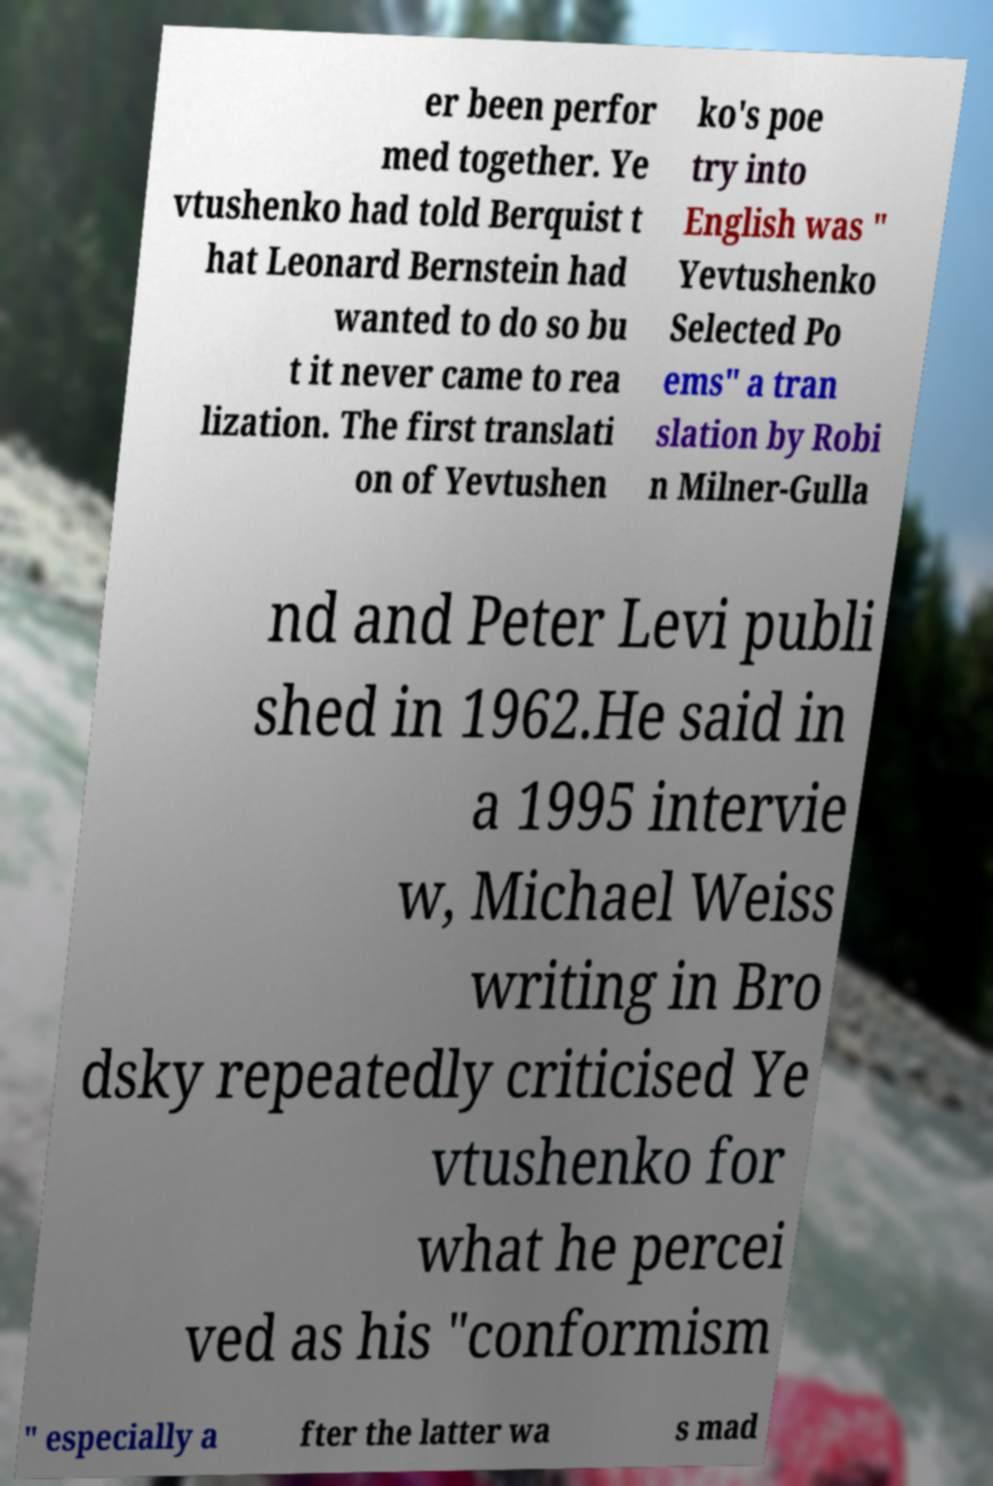What messages or text are displayed in this image? I need them in a readable, typed format. er been perfor med together. Ye vtushenko had told Berquist t hat Leonard Bernstein had wanted to do so bu t it never came to rea lization. The first translati on of Yevtushen ko's poe try into English was " Yevtushenko Selected Po ems" a tran slation by Robi n Milner-Gulla nd and Peter Levi publi shed in 1962.He said in a 1995 intervie w, Michael Weiss writing in Bro dsky repeatedly criticised Ye vtushenko for what he percei ved as his "conformism " especially a fter the latter wa s mad 